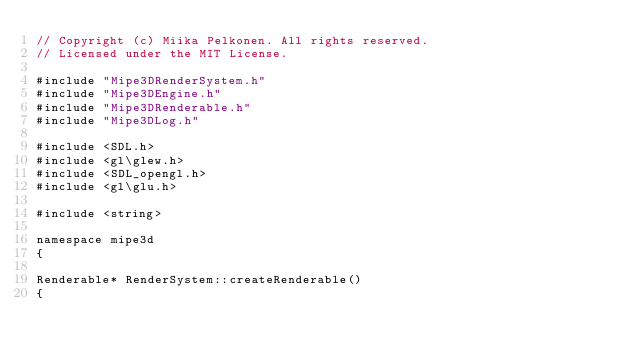Convert code to text. <code><loc_0><loc_0><loc_500><loc_500><_C++_>// Copyright (c) Miika Pelkonen. All rights reserved.
// Licensed under the MIT License.

#include "Mipe3DRenderSystem.h"
#include "Mipe3DEngine.h"
#include "Mipe3DRenderable.h"
#include "Mipe3DLog.h"

#include <SDL.h>
#include <gl\glew.h>
#include <SDL_opengl.h>
#include <gl\glu.h>

#include <string>

namespace mipe3d
{

Renderable* RenderSystem::createRenderable()
{</code> 